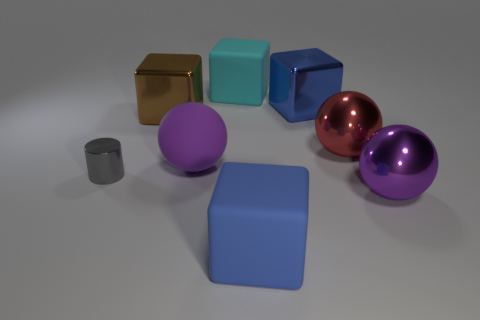Is there any other thing that has the same size as the gray metal object?
Keep it short and to the point. No. How many blue blocks are both behind the red thing and in front of the gray shiny object?
Ensure brevity in your answer.  0. There is a object that is the same color as the large matte ball; what is its shape?
Give a very brief answer. Sphere. What is the thing that is behind the purple matte sphere and left of the cyan object made of?
Provide a short and direct response. Metal. Is the number of large rubber blocks that are to the left of the big rubber ball less than the number of purple matte balls behind the large cyan matte object?
Offer a very short reply. No. What size is the blue thing that is made of the same material as the gray object?
Your response must be concise. Large. Are there any other things that have the same color as the matte ball?
Offer a very short reply. Yes. Are the cyan block and the large blue block in front of the big brown object made of the same material?
Give a very brief answer. Yes. There is a big cyan object that is the same shape as the brown metallic object; what is its material?
Provide a short and direct response. Rubber. Is there anything else that is made of the same material as the large cyan cube?
Give a very brief answer. Yes. 